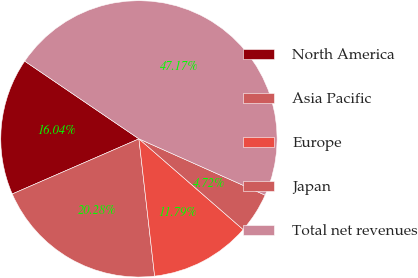<chart> <loc_0><loc_0><loc_500><loc_500><pie_chart><fcel>North America<fcel>Asia Pacific<fcel>Europe<fcel>Japan<fcel>Total net revenues<nl><fcel>16.04%<fcel>20.28%<fcel>11.79%<fcel>4.72%<fcel>47.17%<nl></chart> 